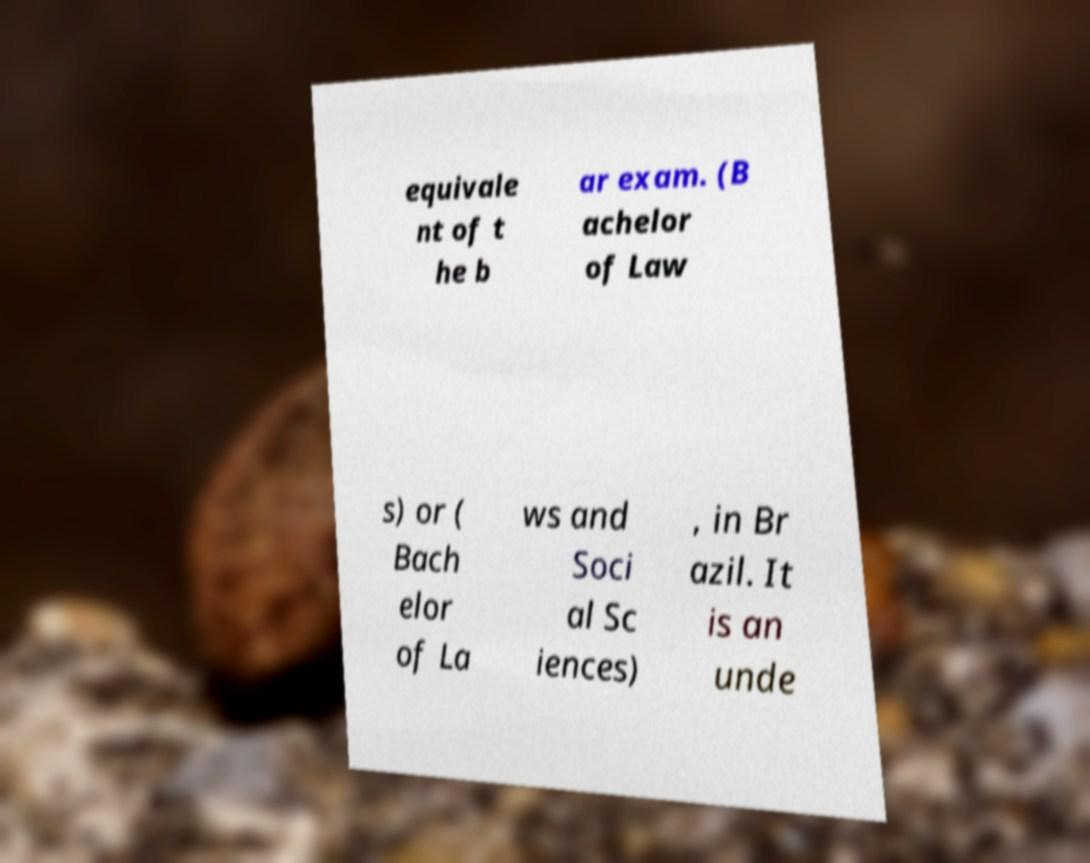I need the written content from this picture converted into text. Can you do that? equivale nt of t he b ar exam. (B achelor of Law s) or ( Bach elor of La ws and Soci al Sc iences) , in Br azil. It is an unde 